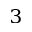Convert formula to latex. <formula><loc_0><loc_0><loc_500><loc_500>^ { 3 }</formula> 